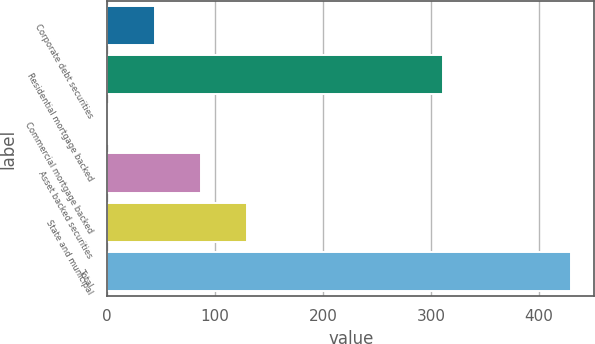Convert chart to OTSL. <chart><loc_0><loc_0><loc_500><loc_500><bar_chart><fcel>Corporate debt securities<fcel>Residential mortgage backed<fcel>Commercial mortgage backed<fcel>Asset backed securities<fcel>State and municipal<fcel>Total<nl><fcel>43.9<fcel>311<fcel>1<fcel>86.8<fcel>129.7<fcel>430<nl></chart> 